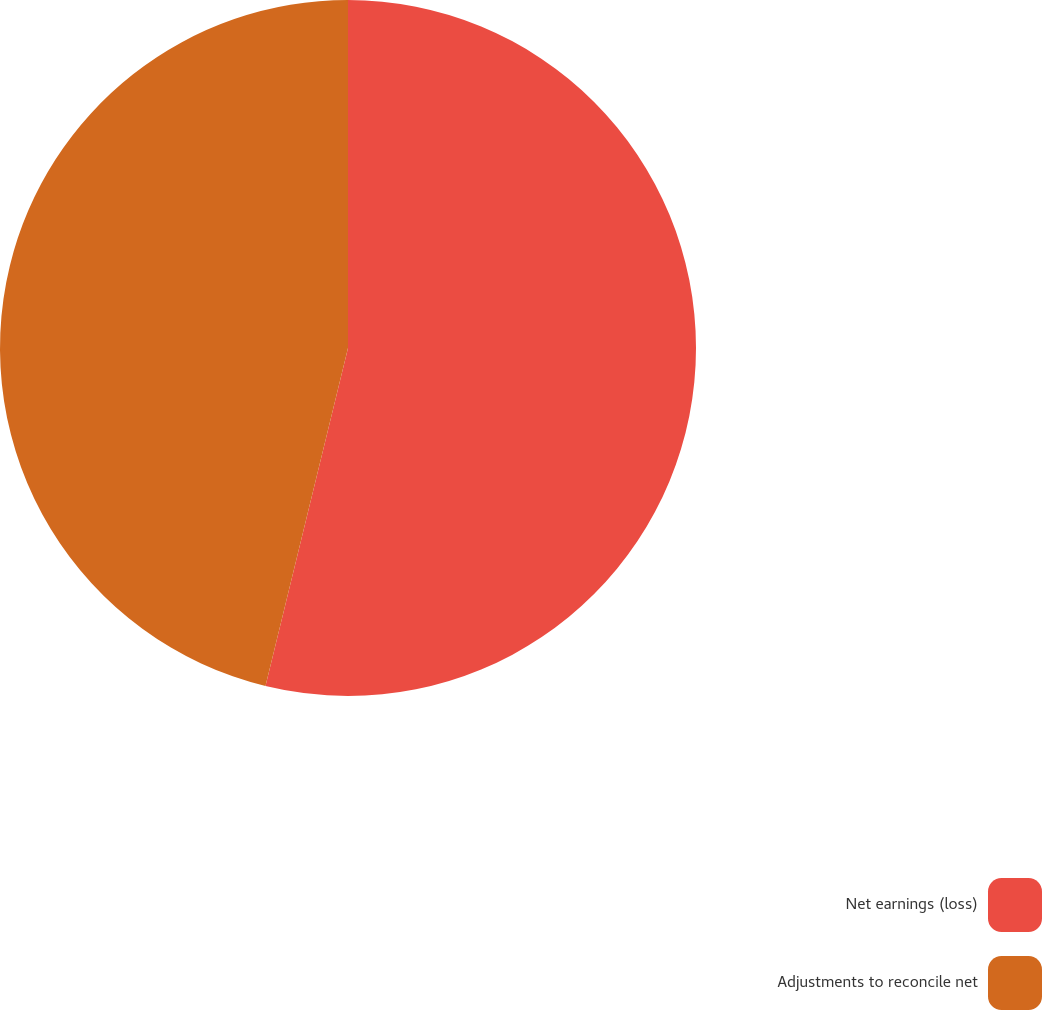Convert chart. <chart><loc_0><loc_0><loc_500><loc_500><pie_chart><fcel>Net earnings (loss)<fcel>Adjustments to reconcile net<nl><fcel>53.81%<fcel>46.19%<nl></chart> 